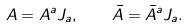Convert formula to latex. <formula><loc_0><loc_0><loc_500><loc_500>A = A ^ { a } J _ { a } , \quad \bar { A } = \bar { A } ^ { a } J _ { a } .</formula> 